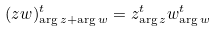Convert formula to latex. <formula><loc_0><loc_0><loc_500><loc_500>( z w ) ^ { t } _ { \arg z + \arg w } = z ^ { t } _ { \arg z } w ^ { t } _ { \arg w }</formula> 